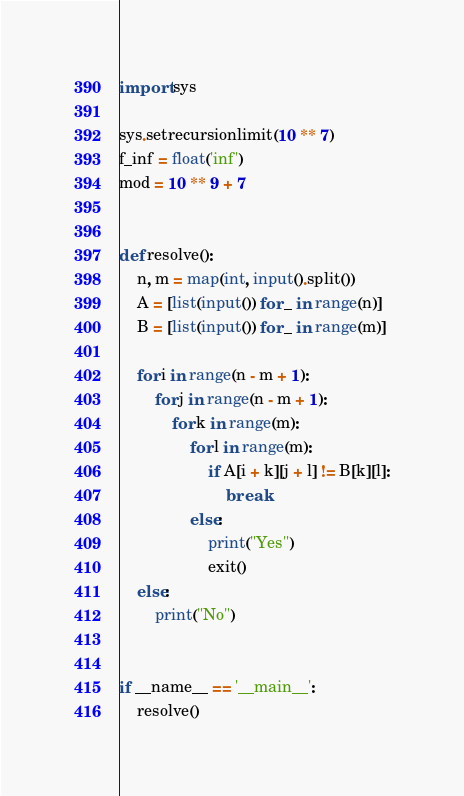<code> <loc_0><loc_0><loc_500><loc_500><_Python_>import sys

sys.setrecursionlimit(10 ** 7)
f_inf = float('inf')
mod = 10 ** 9 + 7


def resolve():
    n, m = map(int, input().split())
    A = [list(input()) for _ in range(n)]
    B = [list(input()) for _ in range(m)]

    for i in range(n - m + 1):
        for j in range(n - m + 1):
            for k in range(m):
                for l in range(m):
                    if A[i + k][j + l] != B[k][l]:
                        break
                else:
                    print("Yes")
                    exit()
    else:
        print("No")


if __name__ == '__main__':
    resolve()
</code> 